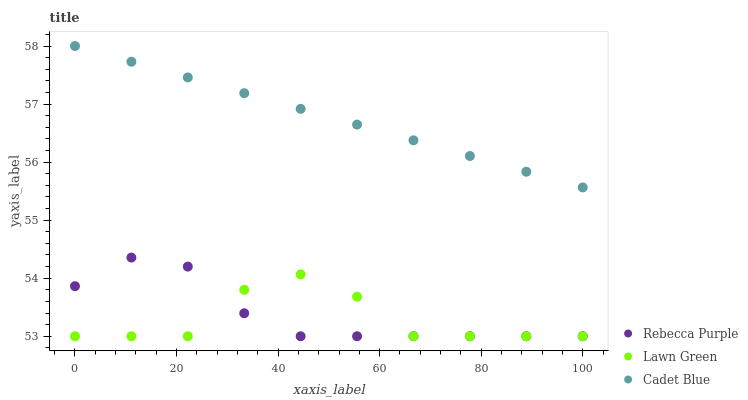Does Lawn Green have the minimum area under the curve?
Answer yes or no. Yes. Does Cadet Blue have the maximum area under the curve?
Answer yes or no. Yes. Does Rebecca Purple have the minimum area under the curve?
Answer yes or no. No. Does Rebecca Purple have the maximum area under the curve?
Answer yes or no. No. Is Cadet Blue the smoothest?
Answer yes or no. Yes. Is Lawn Green the roughest?
Answer yes or no. Yes. Is Rebecca Purple the smoothest?
Answer yes or no. No. Is Rebecca Purple the roughest?
Answer yes or no. No. Does Lawn Green have the lowest value?
Answer yes or no. Yes. Does Cadet Blue have the lowest value?
Answer yes or no. No. Does Cadet Blue have the highest value?
Answer yes or no. Yes. Does Rebecca Purple have the highest value?
Answer yes or no. No. Is Lawn Green less than Cadet Blue?
Answer yes or no. Yes. Is Cadet Blue greater than Lawn Green?
Answer yes or no. Yes. Does Rebecca Purple intersect Lawn Green?
Answer yes or no. Yes. Is Rebecca Purple less than Lawn Green?
Answer yes or no. No. Is Rebecca Purple greater than Lawn Green?
Answer yes or no. No. Does Lawn Green intersect Cadet Blue?
Answer yes or no. No. 